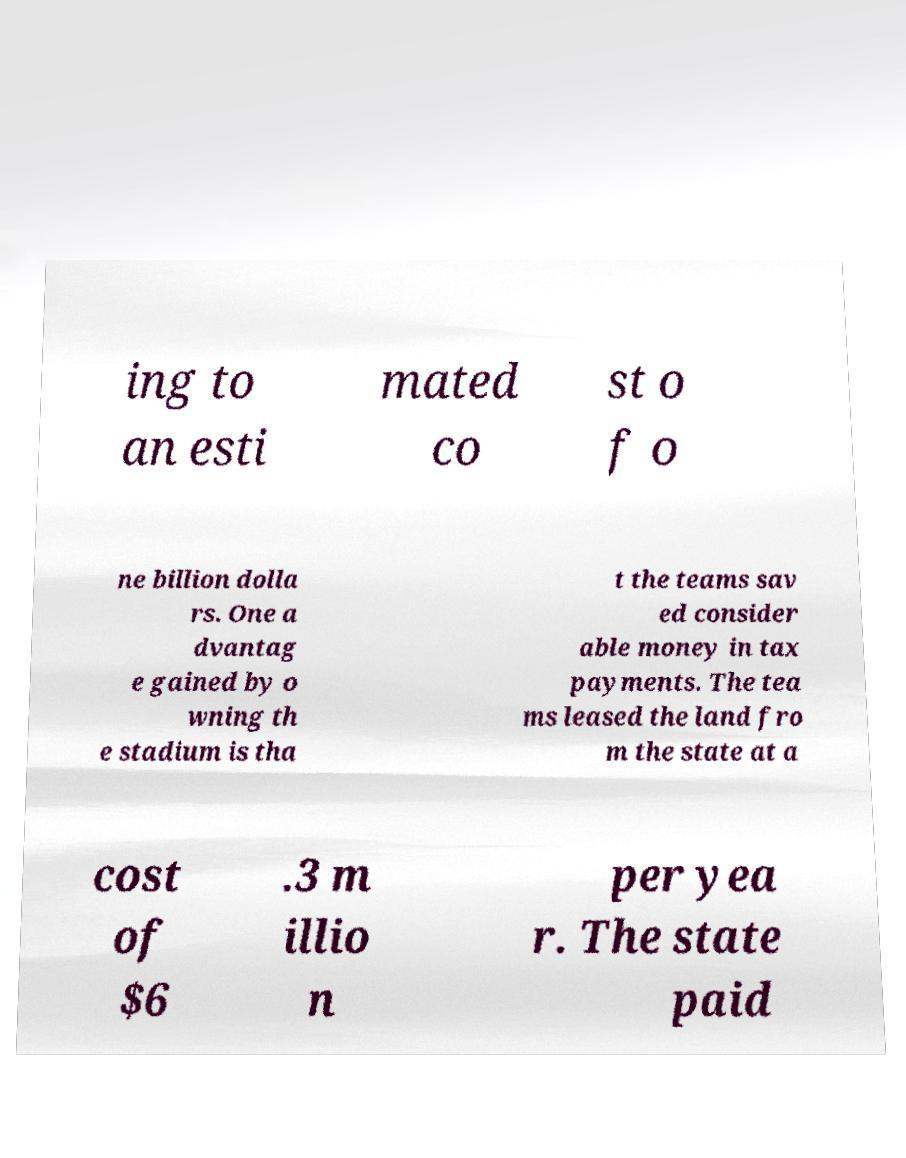Could you extract and type out the text from this image? ing to an esti mated co st o f o ne billion dolla rs. One a dvantag e gained by o wning th e stadium is tha t the teams sav ed consider able money in tax payments. The tea ms leased the land fro m the state at a cost of $6 .3 m illio n per yea r. The state paid 